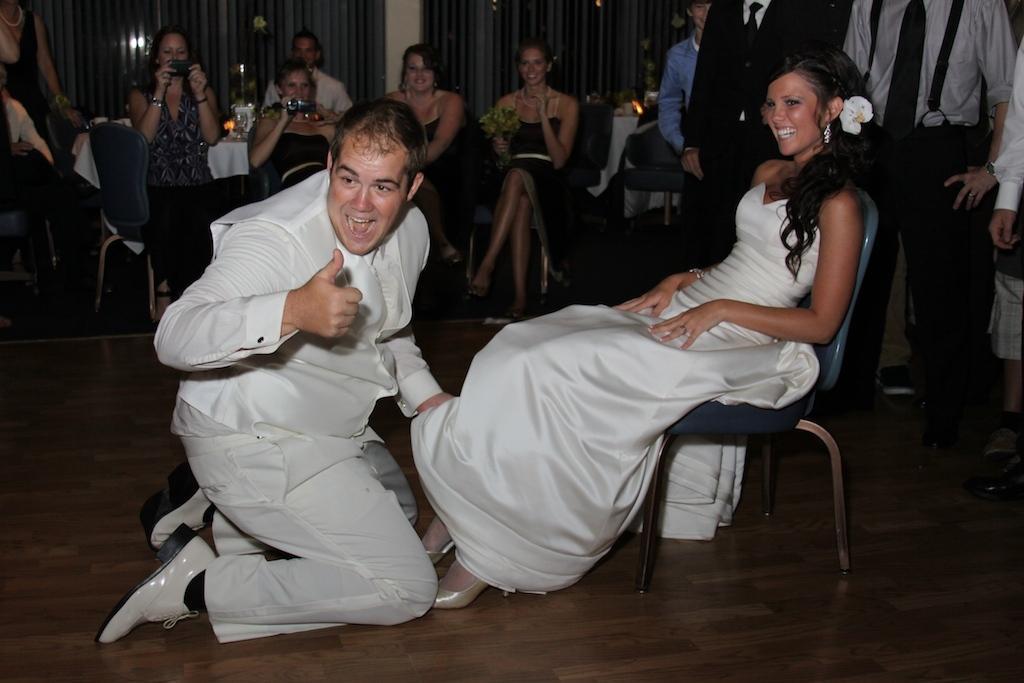How would you summarize this image in a sentence or two? In this image I see a man who is sitting on the floor and i see a woman who is sitting on the chair and both of them are smiling, In the background I see few people in which few of them are sitting and rest of them are standing, I also see few are holding the electronic device. 